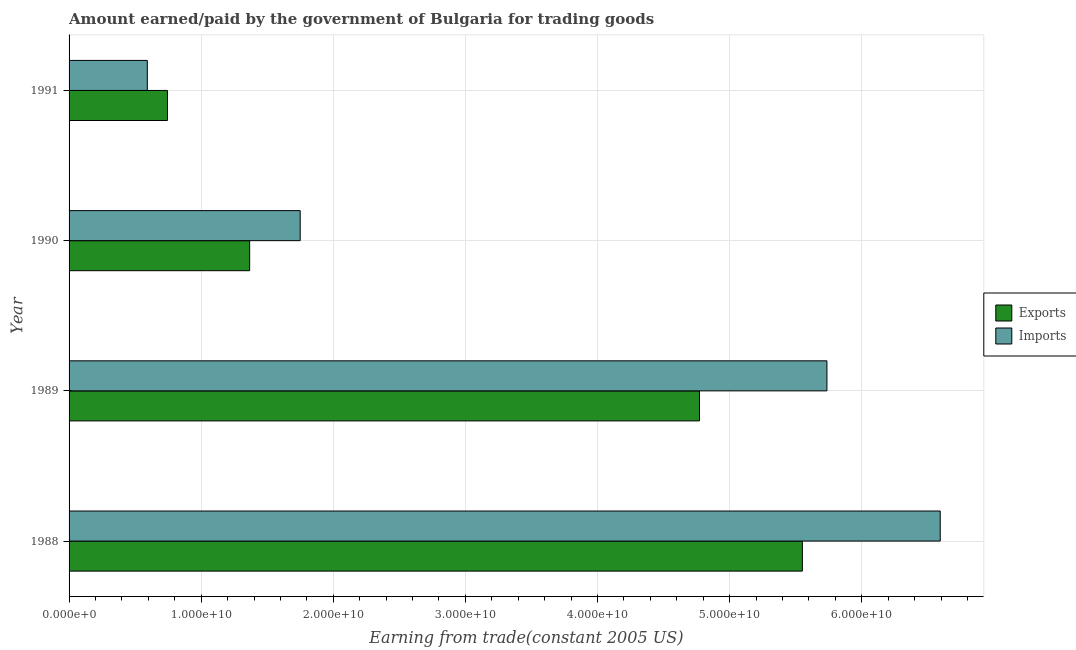Are the number of bars per tick equal to the number of legend labels?
Offer a terse response. Yes. Are the number of bars on each tick of the Y-axis equal?
Give a very brief answer. Yes. How many bars are there on the 2nd tick from the bottom?
Your answer should be compact. 2. What is the amount paid for imports in 1988?
Provide a short and direct response. 6.59e+1. Across all years, what is the maximum amount earned from exports?
Your answer should be compact. 5.55e+1. Across all years, what is the minimum amount earned from exports?
Make the answer very short. 7.45e+09. In which year was the amount earned from exports minimum?
Provide a succinct answer. 1991. What is the total amount earned from exports in the graph?
Your answer should be very brief. 1.24e+11. What is the difference between the amount earned from exports in 1988 and that in 1989?
Your answer should be very brief. 7.79e+09. What is the difference between the amount earned from exports in 1988 and the amount paid for imports in 1991?
Your answer should be compact. 4.96e+1. What is the average amount paid for imports per year?
Provide a succinct answer. 3.67e+1. In the year 1988, what is the difference between the amount paid for imports and amount earned from exports?
Offer a very short reply. 1.04e+1. What is the ratio of the amount earned from exports in 1988 to that in 1990?
Your response must be concise. 4.06. Is the amount paid for imports in 1989 less than that in 1990?
Offer a terse response. No. Is the difference between the amount earned from exports in 1990 and 1991 greater than the difference between the amount paid for imports in 1990 and 1991?
Offer a very short reply. No. What is the difference between the highest and the second highest amount earned from exports?
Keep it short and to the point. 7.79e+09. What is the difference between the highest and the lowest amount paid for imports?
Ensure brevity in your answer.  6.00e+1. In how many years, is the amount earned from exports greater than the average amount earned from exports taken over all years?
Provide a short and direct response. 2. Is the sum of the amount paid for imports in 1990 and 1991 greater than the maximum amount earned from exports across all years?
Give a very brief answer. No. What does the 1st bar from the top in 1990 represents?
Ensure brevity in your answer.  Imports. What does the 1st bar from the bottom in 1988 represents?
Offer a terse response. Exports. How many years are there in the graph?
Offer a very short reply. 4. What is the title of the graph?
Your answer should be very brief. Amount earned/paid by the government of Bulgaria for trading goods. What is the label or title of the X-axis?
Make the answer very short. Earning from trade(constant 2005 US). What is the label or title of the Y-axis?
Offer a terse response. Year. What is the Earning from trade(constant 2005 US) in Exports in 1988?
Make the answer very short. 5.55e+1. What is the Earning from trade(constant 2005 US) in Imports in 1988?
Your answer should be very brief. 6.59e+1. What is the Earning from trade(constant 2005 US) in Exports in 1989?
Your answer should be very brief. 4.77e+1. What is the Earning from trade(constant 2005 US) of Imports in 1989?
Your answer should be very brief. 5.74e+1. What is the Earning from trade(constant 2005 US) in Exports in 1990?
Provide a short and direct response. 1.37e+1. What is the Earning from trade(constant 2005 US) in Imports in 1990?
Your response must be concise. 1.75e+1. What is the Earning from trade(constant 2005 US) in Exports in 1991?
Offer a very short reply. 7.45e+09. What is the Earning from trade(constant 2005 US) of Imports in 1991?
Provide a succinct answer. 5.92e+09. Across all years, what is the maximum Earning from trade(constant 2005 US) of Exports?
Make the answer very short. 5.55e+1. Across all years, what is the maximum Earning from trade(constant 2005 US) of Imports?
Provide a short and direct response. 6.59e+1. Across all years, what is the minimum Earning from trade(constant 2005 US) in Exports?
Give a very brief answer. 7.45e+09. Across all years, what is the minimum Earning from trade(constant 2005 US) of Imports?
Your answer should be compact. 5.92e+09. What is the total Earning from trade(constant 2005 US) in Exports in the graph?
Your answer should be compact. 1.24e+11. What is the total Earning from trade(constant 2005 US) of Imports in the graph?
Your answer should be compact. 1.47e+11. What is the difference between the Earning from trade(constant 2005 US) of Exports in 1988 and that in 1989?
Make the answer very short. 7.79e+09. What is the difference between the Earning from trade(constant 2005 US) of Imports in 1988 and that in 1989?
Provide a succinct answer. 8.58e+09. What is the difference between the Earning from trade(constant 2005 US) in Exports in 1988 and that in 1990?
Offer a very short reply. 4.18e+1. What is the difference between the Earning from trade(constant 2005 US) of Imports in 1988 and that in 1990?
Offer a terse response. 4.84e+1. What is the difference between the Earning from trade(constant 2005 US) in Exports in 1988 and that in 1991?
Your response must be concise. 4.81e+1. What is the difference between the Earning from trade(constant 2005 US) in Imports in 1988 and that in 1991?
Your answer should be compact. 6.00e+1. What is the difference between the Earning from trade(constant 2005 US) of Exports in 1989 and that in 1990?
Your answer should be very brief. 3.40e+1. What is the difference between the Earning from trade(constant 2005 US) of Imports in 1989 and that in 1990?
Provide a succinct answer. 3.99e+1. What is the difference between the Earning from trade(constant 2005 US) in Exports in 1989 and that in 1991?
Provide a succinct answer. 4.03e+1. What is the difference between the Earning from trade(constant 2005 US) of Imports in 1989 and that in 1991?
Your response must be concise. 5.14e+1. What is the difference between the Earning from trade(constant 2005 US) in Exports in 1990 and that in 1991?
Keep it short and to the point. 6.22e+09. What is the difference between the Earning from trade(constant 2005 US) in Imports in 1990 and that in 1991?
Provide a succinct answer. 1.16e+1. What is the difference between the Earning from trade(constant 2005 US) of Exports in 1988 and the Earning from trade(constant 2005 US) of Imports in 1989?
Give a very brief answer. -1.86e+09. What is the difference between the Earning from trade(constant 2005 US) in Exports in 1988 and the Earning from trade(constant 2005 US) in Imports in 1990?
Your answer should be very brief. 3.80e+1. What is the difference between the Earning from trade(constant 2005 US) in Exports in 1988 and the Earning from trade(constant 2005 US) in Imports in 1991?
Your answer should be very brief. 4.96e+1. What is the difference between the Earning from trade(constant 2005 US) of Exports in 1989 and the Earning from trade(constant 2005 US) of Imports in 1990?
Offer a terse response. 3.02e+1. What is the difference between the Earning from trade(constant 2005 US) in Exports in 1989 and the Earning from trade(constant 2005 US) in Imports in 1991?
Your response must be concise. 4.18e+1. What is the difference between the Earning from trade(constant 2005 US) of Exports in 1990 and the Earning from trade(constant 2005 US) of Imports in 1991?
Ensure brevity in your answer.  7.75e+09. What is the average Earning from trade(constant 2005 US) in Exports per year?
Your answer should be compact. 3.11e+1. What is the average Earning from trade(constant 2005 US) of Imports per year?
Make the answer very short. 3.67e+1. In the year 1988, what is the difference between the Earning from trade(constant 2005 US) of Exports and Earning from trade(constant 2005 US) of Imports?
Your response must be concise. -1.04e+1. In the year 1989, what is the difference between the Earning from trade(constant 2005 US) in Exports and Earning from trade(constant 2005 US) in Imports?
Ensure brevity in your answer.  -9.65e+09. In the year 1990, what is the difference between the Earning from trade(constant 2005 US) of Exports and Earning from trade(constant 2005 US) of Imports?
Your answer should be very brief. -3.83e+09. In the year 1991, what is the difference between the Earning from trade(constant 2005 US) in Exports and Earning from trade(constant 2005 US) in Imports?
Give a very brief answer. 1.52e+09. What is the ratio of the Earning from trade(constant 2005 US) in Exports in 1988 to that in 1989?
Your answer should be compact. 1.16. What is the ratio of the Earning from trade(constant 2005 US) in Imports in 1988 to that in 1989?
Give a very brief answer. 1.15. What is the ratio of the Earning from trade(constant 2005 US) of Exports in 1988 to that in 1990?
Keep it short and to the point. 4.06. What is the ratio of the Earning from trade(constant 2005 US) in Imports in 1988 to that in 1990?
Keep it short and to the point. 3.77. What is the ratio of the Earning from trade(constant 2005 US) in Exports in 1988 to that in 1991?
Make the answer very short. 7.45. What is the ratio of the Earning from trade(constant 2005 US) of Imports in 1988 to that in 1991?
Give a very brief answer. 11.13. What is the ratio of the Earning from trade(constant 2005 US) of Exports in 1989 to that in 1990?
Offer a very short reply. 3.49. What is the ratio of the Earning from trade(constant 2005 US) in Imports in 1989 to that in 1990?
Your response must be concise. 3.28. What is the ratio of the Earning from trade(constant 2005 US) in Exports in 1989 to that in 1991?
Your answer should be very brief. 6.41. What is the ratio of the Earning from trade(constant 2005 US) of Imports in 1989 to that in 1991?
Keep it short and to the point. 9.69. What is the ratio of the Earning from trade(constant 2005 US) in Exports in 1990 to that in 1991?
Provide a succinct answer. 1.84. What is the ratio of the Earning from trade(constant 2005 US) of Imports in 1990 to that in 1991?
Your answer should be compact. 2.95. What is the difference between the highest and the second highest Earning from trade(constant 2005 US) of Exports?
Provide a succinct answer. 7.79e+09. What is the difference between the highest and the second highest Earning from trade(constant 2005 US) of Imports?
Provide a succinct answer. 8.58e+09. What is the difference between the highest and the lowest Earning from trade(constant 2005 US) of Exports?
Keep it short and to the point. 4.81e+1. What is the difference between the highest and the lowest Earning from trade(constant 2005 US) in Imports?
Ensure brevity in your answer.  6.00e+1. 